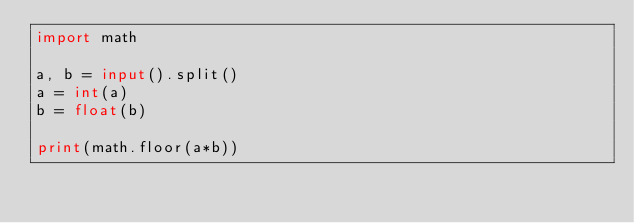<code> <loc_0><loc_0><loc_500><loc_500><_Python_>import math

a, b = input().split()
a = int(a)
b = float(b)

print(math.floor(a*b))
</code> 